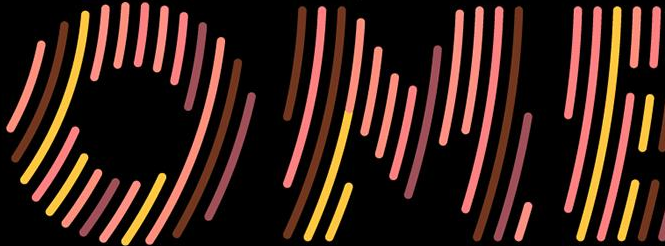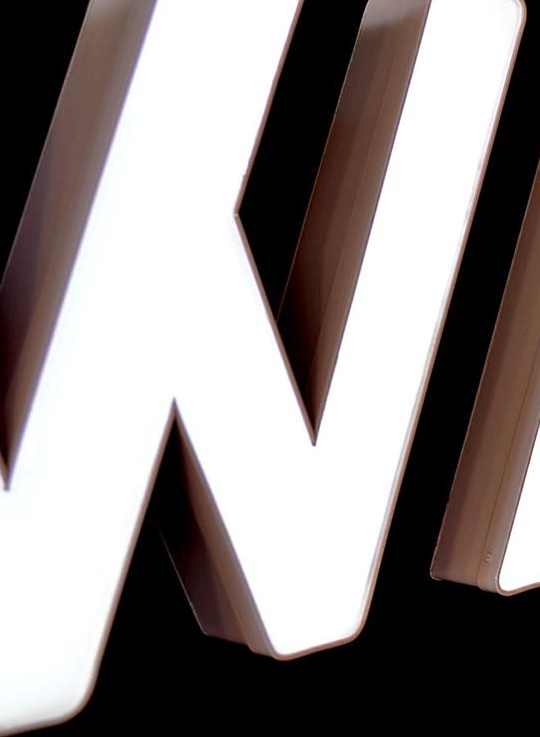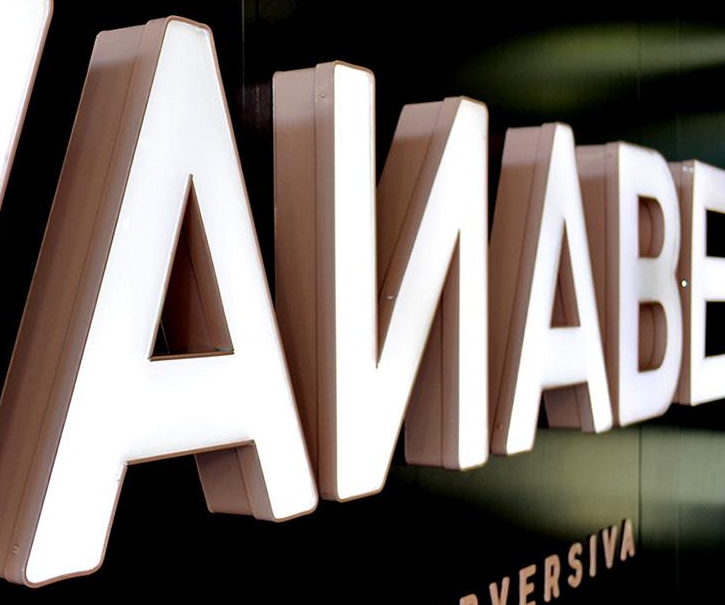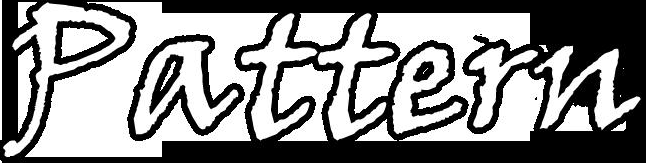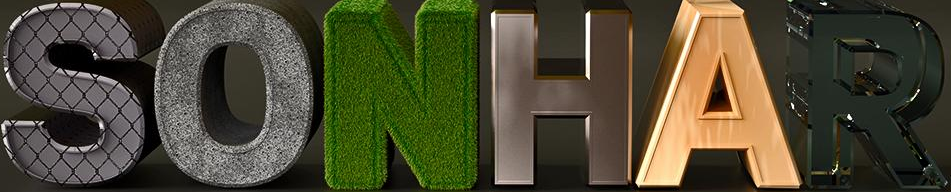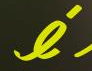Transcribe the words shown in these images in order, separated by a semicolon. OME; #; AИABE; Pattern; SONHAR; é 